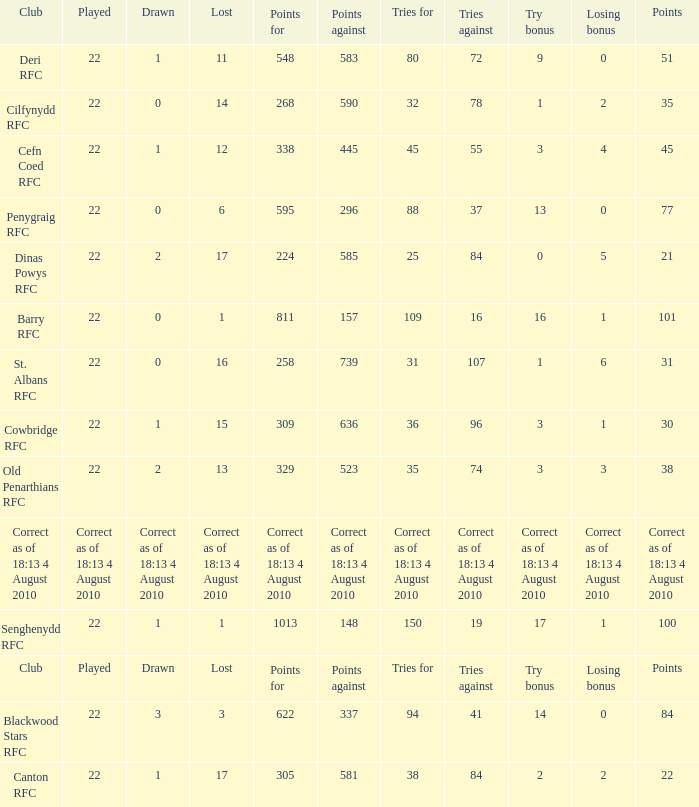What is the name of the club when the played number is 22, and the try bonus was 0? Dinas Powys RFC. Write the full table. {'header': ['Club', 'Played', 'Drawn', 'Lost', 'Points for', 'Points against', 'Tries for', 'Tries against', 'Try bonus', 'Losing bonus', 'Points'], 'rows': [['Deri RFC', '22', '1', '11', '548', '583', '80', '72', '9', '0', '51'], ['Cilfynydd RFC', '22', '0', '14', '268', '590', '32', '78', '1', '2', '35'], ['Cefn Coed RFC', '22', '1', '12', '338', '445', '45', '55', '3', '4', '45'], ['Penygraig RFC', '22', '0', '6', '595', '296', '88', '37', '13', '0', '77'], ['Dinas Powys RFC', '22', '2', '17', '224', '585', '25', '84', '0', '5', '21'], ['Barry RFC', '22', '0', '1', '811', '157', '109', '16', '16', '1', '101'], ['St. Albans RFC', '22', '0', '16', '258', '739', '31', '107', '1', '6', '31'], ['Cowbridge RFC', '22', '1', '15', '309', '636', '36', '96', '3', '1', '30'], ['Old Penarthians RFC', '22', '2', '13', '329', '523', '35', '74', '3', '3', '38'], ['Correct as of 18:13 4 August 2010', 'Correct as of 18:13 4 August 2010', 'Correct as of 18:13 4 August 2010', 'Correct as of 18:13 4 August 2010', 'Correct as of 18:13 4 August 2010', 'Correct as of 18:13 4 August 2010', 'Correct as of 18:13 4 August 2010', 'Correct as of 18:13 4 August 2010', 'Correct as of 18:13 4 August 2010', 'Correct as of 18:13 4 August 2010', 'Correct as of 18:13 4 August 2010'], ['Senghenydd RFC', '22', '1', '1', '1013', '148', '150', '19', '17', '1', '100'], ['Club', 'Played', 'Drawn', 'Lost', 'Points for', 'Points against', 'Tries for', 'Tries against', 'Try bonus', 'Losing bonus', 'Points'], ['Blackwood Stars RFC', '22', '3', '3', '622', '337', '94', '41', '14', '0', '84'], ['Canton RFC', '22', '1', '17', '305', '581', '38', '84', '2', '2', '22']]} 